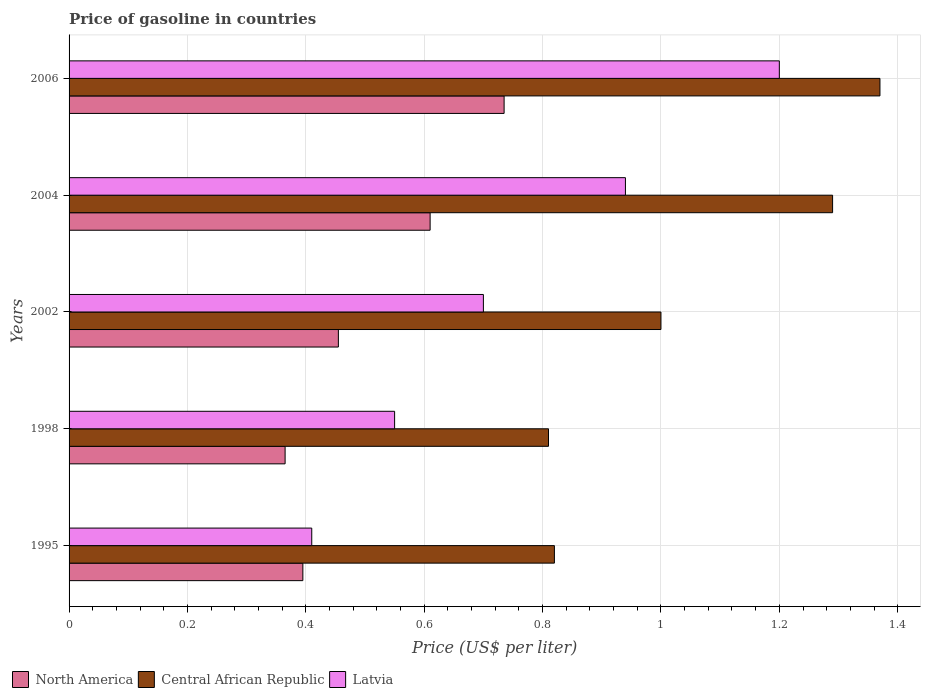Are the number of bars on each tick of the Y-axis equal?
Offer a terse response. Yes. What is the price of gasoline in Central African Republic in 2006?
Your response must be concise. 1.37. Across all years, what is the maximum price of gasoline in North America?
Provide a succinct answer. 0.73. Across all years, what is the minimum price of gasoline in North America?
Your response must be concise. 0.36. In which year was the price of gasoline in North America minimum?
Keep it short and to the point. 1998. What is the total price of gasoline in Latvia in the graph?
Provide a short and direct response. 3.8. What is the difference between the price of gasoline in Latvia in 1995 and that in 2002?
Offer a very short reply. -0.29. What is the difference between the price of gasoline in North America in 2004 and the price of gasoline in Central African Republic in 1995?
Provide a short and direct response. -0.21. What is the average price of gasoline in Central African Republic per year?
Provide a short and direct response. 1.06. In the year 1998, what is the difference between the price of gasoline in Latvia and price of gasoline in North America?
Offer a terse response. 0.19. In how many years, is the price of gasoline in Central African Republic greater than 0.9600000000000001 US$?
Offer a terse response. 3. What is the ratio of the price of gasoline in North America in 1998 to that in 2002?
Make the answer very short. 0.8. Is the difference between the price of gasoline in Latvia in 2002 and 2006 greater than the difference between the price of gasoline in North America in 2002 and 2006?
Offer a terse response. No. What is the difference between the highest and the second highest price of gasoline in Latvia?
Give a very brief answer. 0.26. What is the difference between the highest and the lowest price of gasoline in Central African Republic?
Offer a very short reply. 0.56. In how many years, is the price of gasoline in North America greater than the average price of gasoline in North America taken over all years?
Keep it short and to the point. 2. Is the sum of the price of gasoline in North America in 1995 and 2002 greater than the maximum price of gasoline in Latvia across all years?
Offer a terse response. No. What does the 3rd bar from the top in 1998 represents?
Offer a terse response. North America. What does the 1st bar from the bottom in 2002 represents?
Provide a succinct answer. North America. Is it the case that in every year, the sum of the price of gasoline in Latvia and price of gasoline in Central African Republic is greater than the price of gasoline in North America?
Provide a succinct answer. Yes. How many bars are there?
Ensure brevity in your answer.  15. Are all the bars in the graph horizontal?
Your response must be concise. Yes. Are the values on the major ticks of X-axis written in scientific E-notation?
Ensure brevity in your answer.  No. Does the graph contain grids?
Ensure brevity in your answer.  Yes. How are the legend labels stacked?
Your answer should be very brief. Horizontal. What is the title of the graph?
Keep it short and to the point. Price of gasoline in countries. What is the label or title of the X-axis?
Give a very brief answer. Price (US$ per liter). What is the Price (US$ per liter) of North America in 1995?
Provide a succinct answer. 0.4. What is the Price (US$ per liter) in Central African Republic in 1995?
Provide a short and direct response. 0.82. What is the Price (US$ per liter) of Latvia in 1995?
Make the answer very short. 0.41. What is the Price (US$ per liter) of North America in 1998?
Provide a short and direct response. 0.36. What is the Price (US$ per liter) in Central African Republic in 1998?
Offer a very short reply. 0.81. What is the Price (US$ per liter) of Latvia in 1998?
Your answer should be compact. 0.55. What is the Price (US$ per liter) of North America in 2002?
Your response must be concise. 0.46. What is the Price (US$ per liter) of Central African Republic in 2002?
Offer a very short reply. 1. What is the Price (US$ per liter) of Latvia in 2002?
Offer a very short reply. 0.7. What is the Price (US$ per liter) in North America in 2004?
Give a very brief answer. 0.61. What is the Price (US$ per liter) of Central African Republic in 2004?
Offer a terse response. 1.29. What is the Price (US$ per liter) of North America in 2006?
Offer a terse response. 0.73. What is the Price (US$ per liter) of Central African Republic in 2006?
Provide a succinct answer. 1.37. Across all years, what is the maximum Price (US$ per liter) of North America?
Your answer should be compact. 0.73. Across all years, what is the maximum Price (US$ per liter) in Central African Republic?
Offer a terse response. 1.37. Across all years, what is the minimum Price (US$ per liter) in North America?
Give a very brief answer. 0.36. Across all years, what is the minimum Price (US$ per liter) of Central African Republic?
Provide a short and direct response. 0.81. Across all years, what is the minimum Price (US$ per liter) in Latvia?
Give a very brief answer. 0.41. What is the total Price (US$ per liter) of North America in the graph?
Provide a short and direct response. 2.56. What is the total Price (US$ per liter) of Central African Republic in the graph?
Offer a terse response. 5.29. What is the difference between the Price (US$ per liter) of Latvia in 1995 and that in 1998?
Provide a succinct answer. -0.14. What is the difference between the Price (US$ per liter) of North America in 1995 and that in 2002?
Keep it short and to the point. -0.06. What is the difference between the Price (US$ per liter) in Central African Republic in 1995 and that in 2002?
Provide a short and direct response. -0.18. What is the difference between the Price (US$ per liter) of Latvia in 1995 and that in 2002?
Make the answer very short. -0.29. What is the difference between the Price (US$ per liter) in North America in 1995 and that in 2004?
Your answer should be compact. -0.21. What is the difference between the Price (US$ per liter) of Central African Republic in 1995 and that in 2004?
Your answer should be compact. -0.47. What is the difference between the Price (US$ per liter) in Latvia in 1995 and that in 2004?
Offer a very short reply. -0.53. What is the difference between the Price (US$ per liter) in North America in 1995 and that in 2006?
Keep it short and to the point. -0.34. What is the difference between the Price (US$ per liter) in Central African Republic in 1995 and that in 2006?
Provide a succinct answer. -0.55. What is the difference between the Price (US$ per liter) of Latvia in 1995 and that in 2006?
Make the answer very short. -0.79. What is the difference between the Price (US$ per liter) in North America in 1998 and that in 2002?
Your answer should be compact. -0.09. What is the difference between the Price (US$ per liter) in Central African Republic in 1998 and that in 2002?
Offer a terse response. -0.19. What is the difference between the Price (US$ per liter) in North America in 1998 and that in 2004?
Make the answer very short. -0.24. What is the difference between the Price (US$ per liter) of Central African Republic in 1998 and that in 2004?
Give a very brief answer. -0.48. What is the difference between the Price (US$ per liter) in Latvia in 1998 and that in 2004?
Give a very brief answer. -0.39. What is the difference between the Price (US$ per liter) of North America in 1998 and that in 2006?
Offer a terse response. -0.37. What is the difference between the Price (US$ per liter) of Central African Republic in 1998 and that in 2006?
Provide a short and direct response. -0.56. What is the difference between the Price (US$ per liter) in Latvia in 1998 and that in 2006?
Provide a succinct answer. -0.65. What is the difference between the Price (US$ per liter) of North America in 2002 and that in 2004?
Provide a succinct answer. -0.15. What is the difference between the Price (US$ per liter) in Central African Republic in 2002 and that in 2004?
Your answer should be very brief. -0.29. What is the difference between the Price (US$ per liter) of Latvia in 2002 and that in 2004?
Make the answer very short. -0.24. What is the difference between the Price (US$ per liter) of North America in 2002 and that in 2006?
Your answer should be very brief. -0.28. What is the difference between the Price (US$ per liter) in Central African Republic in 2002 and that in 2006?
Offer a terse response. -0.37. What is the difference between the Price (US$ per liter) in Latvia in 2002 and that in 2006?
Your answer should be compact. -0.5. What is the difference between the Price (US$ per liter) of North America in 2004 and that in 2006?
Make the answer very short. -0.12. What is the difference between the Price (US$ per liter) of Central African Republic in 2004 and that in 2006?
Provide a succinct answer. -0.08. What is the difference between the Price (US$ per liter) of Latvia in 2004 and that in 2006?
Ensure brevity in your answer.  -0.26. What is the difference between the Price (US$ per liter) of North America in 1995 and the Price (US$ per liter) of Central African Republic in 1998?
Offer a very short reply. -0.41. What is the difference between the Price (US$ per liter) of North America in 1995 and the Price (US$ per liter) of Latvia in 1998?
Give a very brief answer. -0.15. What is the difference between the Price (US$ per liter) in Central African Republic in 1995 and the Price (US$ per liter) in Latvia in 1998?
Ensure brevity in your answer.  0.27. What is the difference between the Price (US$ per liter) of North America in 1995 and the Price (US$ per liter) of Central African Republic in 2002?
Keep it short and to the point. -0.6. What is the difference between the Price (US$ per liter) in North America in 1995 and the Price (US$ per liter) in Latvia in 2002?
Provide a succinct answer. -0.3. What is the difference between the Price (US$ per liter) of Central African Republic in 1995 and the Price (US$ per liter) of Latvia in 2002?
Give a very brief answer. 0.12. What is the difference between the Price (US$ per liter) in North America in 1995 and the Price (US$ per liter) in Central African Republic in 2004?
Provide a short and direct response. -0.9. What is the difference between the Price (US$ per liter) in North America in 1995 and the Price (US$ per liter) in Latvia in 2004?
Your answer should be compact. -0.55. What is the difference between the Price (US$ per liter) in Central African Republic in 1995 and the Price (US$ per liter) in Latvia in 2004?
Offer a very short reply. -0.12. What is the difference between the Price (US$ per liter) in North America in 1995 and the Price (US$ per liter) in Central African Republic in 2006?
Provide a succinct answer. -0.97. What is the difference between the Price (US$ per liter) in North America in 1995 and the Price (US$ per liter) in Latvia in 2006?
Your answer should be very brief. -0.81. What is the difference between the Price (US$ per liter) of Central African Republic in 1995 and the Price (US$ per liter) of Latvia in 2006?
Your answer should be compact. -0.38. What is the difference between the Price (US$ per liter) of North America in 1998 and the Price (US$ per liter) of Central African Republic in 2002?
Your response must be concise. -0.64. What is the difference between the Price (US$ per liter) of North America in 1998 and the Price (US$ per liter) of Latvia in 2002?
Make the answer very short. -0.34. What is the difference between the Price (US$ per liter) in Central African Republic in 1998 and the Price (US$ per liter) in Latvia in 2002?
Your answer should be compact. 0.11. What is the difference between the Price (US$ per liter) of North America in 1998 and the Price (US$ per liter) of Central African Republic in 2004?
Ensure brevity in your answer.  -0.93. What is the difference between the Price (US$ per liter) of North America in 1998 and the Price (US$ per liter) of Latvia in 2004?
Make the answer very short. -0.57. What is the difference between the Price (US$ per liter) in Central African Republic in 1998 and the Price (US$ per liter) in Latvia in 2004?
Your answer should be compact. -0.13. What is the difference between the Price (US$ per liter) of North America in 1998 and the Price (US$ per liter) of Central African Republic in 2006?
Keep it short and to the point. -1. What is the difference between the Price (US$ per liter) in North America in 1998 and the Price (US$ per liter) in Latvia in 2006?
Give a very brief answer. -0.83. What is the difference between the Price (US$ per liter) of Central African Republic in 1998 and the Price (US$ per liter) of Latvia in 2006?
Provide a short and direct response. -0.39. What is the difference between the Price (US$ per liter) of North America in 2002 and the Price (US$ per liter) of Central African Republic in 2004?
Ensure brevity in your answer.  -0.83. What is the difference between the Price (US$ per liter) of North America in 2002 and the Price (US$ per liter) of Latvia in 2004?
Your response must be concise. -0.48. What is the difference between the Price (US$ per liter) in North America in 2002 and the Price (US$ per liter) in Central African Republic in 2006?
Provide a short and direct response. -0.92. What is the difference between the Price (US$ per liter) in North America in 2002 and the Price (US$ per liter) in Latvia in 2006?
Your answer should be compact. -0.74. What is the difference between the Price (US$ per liter) of North America in 2004 and the Price (US$ per liter) of Central African Republic in 2006?
Your answer should be very brief. -0.76. What is the difference between the Price (US$ per liter) of North America in 2004 and the Price (US$ per liter) of Latvia in 2006?
Your answer should be compact. -0.59. What is the difference between the Price (US$ per liter) in Central African Republic in 2004 and the Price (US$ per liter) in Latvia in 2006?
Provide a succinct answer. 0.09. What is the average Price (US$ per liter) of North America per year?
Offer a very short reply. 0.51. What is the average Price (US$ per liter) in Central African Republic per year?
Give a very brief answer. 1.06. What is the average Price (US$ per liter) in Latvia per year?
Your response must be concise. 0.76. In the year 1995, what is the difference between the Price (US$ per liter) in North America and Price (US$ per liter) in Central African Republic?
Ensure brevity in your answer.  -0.42. In the year 1995, what is the difference between the Price (US$ per liter) in North America and Price (US$ per liter) in Latvia?
Your response must be concise. -0.01. In the year 1995, what is the difference between the Price (US$ per liter) in Central African Republic and Price (US$ per liter) in Latvia?
Keep it short and to the point. 0.41. In the year 1998, what is the difference between the Price (US$ per liter) of North America and Price (US$ per liter) of Central African Republic?
Give a very brief answer. -0.45. In the year 1998, what is the difference between the Price (US$ per liter) in North America and Price (US$ per liter) in Latvia?
Your response must be concise. -0.18. In the year 1998, what is the difference between the Price (US$ per liter) of Central African Republic and Price (US$ per liter) of Latvia?
Give a very brief answer. 0.26. In the year 2002, what is the difference between the Price (US$ per liter) in North America and Price (US$ per liter) in Central African Republic?
Give a very brief answer. -0.55. In the year 2002, what is the difference between the Price (US$ per liter) in North America and Price (US$ per liter) in Latvia?
Give a very brief answer. -0.24. In the year 2004, what is the difference between the Price (US$ per liter) of North America and Price (US$ per liter) of Central African Republic?
Your answer should be compact. -0.68. In the year 2004, what is the difference between the Price (US$ per liter) in North America and Price (US$ per liter) in Latvia?
Provide a short and direct response. -0.33. In the year 2006, what is the difference between the Price (US$ per liter) in North America and Price (US$ per liter) in Central African Republic?
Your response must be concise. -0.64. In the year 2006, what is the difference between the Price (US$ per liter) of North America and Price (US$ per liter) of Latvia?
Make the answer very short. -0.47. In the year 2006, what is the difference between the Price (US$ per liter) in Central African Republic and Price (US$ per liter) in Latvia?
Provide a succinct answer. 0.17. What is the ratio of the Price (US$ per liter) of North America in 1995 to that in 1998?
Make the answer very short. 1.08. What is the ratio of the Price (US$ per liter) of Central African Republic in 1995 to that in 1998?
Your answer should be compact. 1.01. What is the ratio of the Price (US$ per liter) in Latvia in 1995 to that in 1998?
Make the answer very short. 0.75. What is the ratio of the Price (US$ per liter) of North America in 1995 to that in 2002?
Keep it short and to the point. 0.87. What is the ratio of the Price (US$ per liter) of Central African Republic in 1995 to that in 2002?
Your response must be concise. 0.82. What is the ratio of the Price (US$ per liter) in Latvia in 1995 to that in 2002?
Keep it short and to the point. 0.59. What is the ratio of the Price (US$ per liter) of North America in 1995 to that in 2004?
Offer a very short reply. 0.65. What is the ratio of the Price (US$ per liter) of Central African Republic in 1995 to that in 2004?
Give a very brief answer. 0.64. What is the ratio of the Price (US$ per liter) of Latvia in 1995 to that in 2004?
Provide a short and direct response. 0.44. What is the ratio of the Price (US$ per liter) in North America in 1995 to that in 2006?
Your response must be concise. 0.54. What is the ratio of the Price (US$ per liter) in Central African Republic in 1995 to that in 2006?
Your response must be concise. 0.6. What is the ratio of the Price (US$ per liter) in Latvia in 1995 to that in 2006?
Your answer should be very brief. 0.34. What is the ratio of the Price (US$ per liter) of North America in 1998 to that in 2002?
Keep it short and to the point. 0.8. What is the ratio of the Price (US$ per liter) of Central African Republic in 1998 to that in 2002?
Your answer should be compact. 0.81. What is the ratio of the Price (US$ per liter) of Latvia in 1998 to that in 2002?
Your answer should be very brief. 0.79. What is the ratio of the Price (US$ per liter) of North America in 1998 to that in 2004?
Keep it short and to the point. 0.6. What is the ratio of the Price (US$ per liter) of Central African Republic in 1998 to that in 2004?
Provide a short and direct response. 0.63. What is the ratio of the Price (US$ per liter) of Latvia in 1998 to that in 2004?
Make the answer very short. 0.59. What is the ratio of the Price (US$ per liter) of North America in 1998 to that in 2006?
Your answer should be very brief. 0.5. What is the ratio of the Price (US$ per liter) of Central African Republic in 1998 to that in 2006?
Provide a succinct answer. 0.59. What is the ratio of the Price (US$ per liter) in Latvia in 1998 to that in 2006?
Provide a short and direct response. 0.46. What is the ratio of the Price (US$ per liter) in North America in 2002 to that in 2004?
Provide a succinct answer. 0.75. What is the ratio of the Price (US$ per liter) in Central African Republic in 2002 to that in 2004?
Offer a very short reply. 0.78. What is the ratio of the Price (US$ per liter) in Latvia in 2002 to that in 2004?
Your response must be concise. 0.74. What is the ratio of the Price (US$ per liter) of North America in 2002 to that in 2006?
Provide a succinct answer. 0.62. What is the ratio of the Price (US$ per liter) of Central African Republic in 2002 to that in 2006?
Offer a very short reply. 0.73. What is the ratio of the Price (US$ per liter) of Latvia in 2002 to that in 2006?
Provide a short and direct response. 0.58. What is the ratio of the Price (US$ per liter) of North America in 2004 to that in 2006?
Your answer should be very brief. 0.83. What is the ratio of the Price (US$ per liter) in Central African Republic in 2004 to that in 2006?
Provide a succinct answer. 0.94. What is the ratio of the Price (US$ per liter) of Latvia in 2004 to that in 2006?
Keep it short and to the point. 0.78. What is the difference between the highest and the second highest Price (US$ per liter) of Central African Republic?
Give a very brief answer. 0.08. What is the difference between the highest and the second highest Price (US$ per liter) of Latvia?
Your response must be concise. 0.26. What is the difference between the highest and the lowest Price (US$ per liter) of North America?
Offer a very short reply. 0.37. What is the difference between the highest and the lowest Price (US$ per liter) of Central African Republic?
Ensure brevity in your answer.  0.56. What is the difference between the highest and the lowest Price (US$ per liter) in Latvia?
Ensure brevity in your answer.  0.79. 